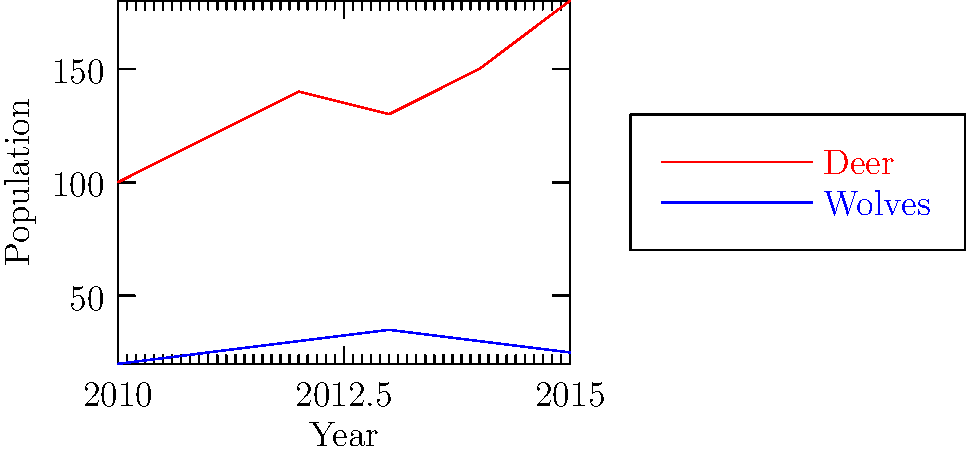Analyzing the line graph depicting deer and wolf populations from 2010 to 2015, which year shows the most significant divergence in population trends between the two species, and what might this indicate about their ecological relationship? To answer this question, we need to analyze the population trends of both deer and wolves year by year:

1. 2010-2011: Both populations increase slightly.
2. 2011-2012: Both populations continue to increase.
3. 2012-2013: Deer population slightly decreases, while wolf population continues to increase.
4. 2013-2014: Deer population increases, while wolf population decreases.
5. 2014-2015: Deer population increases significantly, while wolf population continues to decrease.

The most significant divergence occurs in 2014-2015, where the deer population shows a sharp increase while the wolf population decreases.

This divergence could indicate:

1. A breakdown in the predator-prey relationship, possibly due to external factors affecting wolf hunting success or deer vulnerability.
2. Human intervention, such as wolf control measures or deer conservation efforts.
3. Changes in habitat or food availability favoring deer but not wolves.
4. Disease affecting the wolf population while deer thrive.

As a seasoned ranger, this divergence would be a critical point of interest, potentially signaling an imbalance in the ecosystem that may require further investigation or management intervention.
Answer: 2014-2015; predator-prey imbalance 